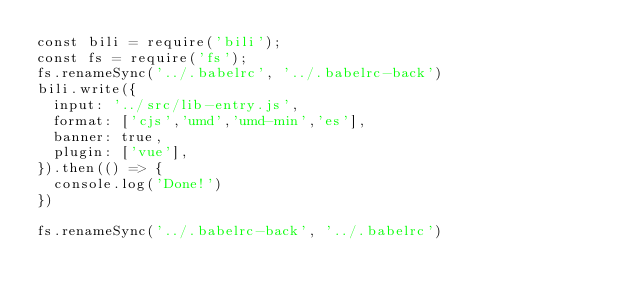Convert code to text. <code><loc_0><loc_0><loc_500><loc_500><_JavaScript_>const bili = require('bili');
const fs = require('fs');
fs.renameSync('../.babelrc', '../.babelrc-back')
bili.write({
  input: '../src/lib-entry.js',
  format: ['cjs','umd','umd-min','es'],
  banner: true,
  plugin: ['vue'],
}).then(() => {
  console.log('Done!')
})

fs.renameSync('../.babelrc-back', '../.babelrc')
</code> 